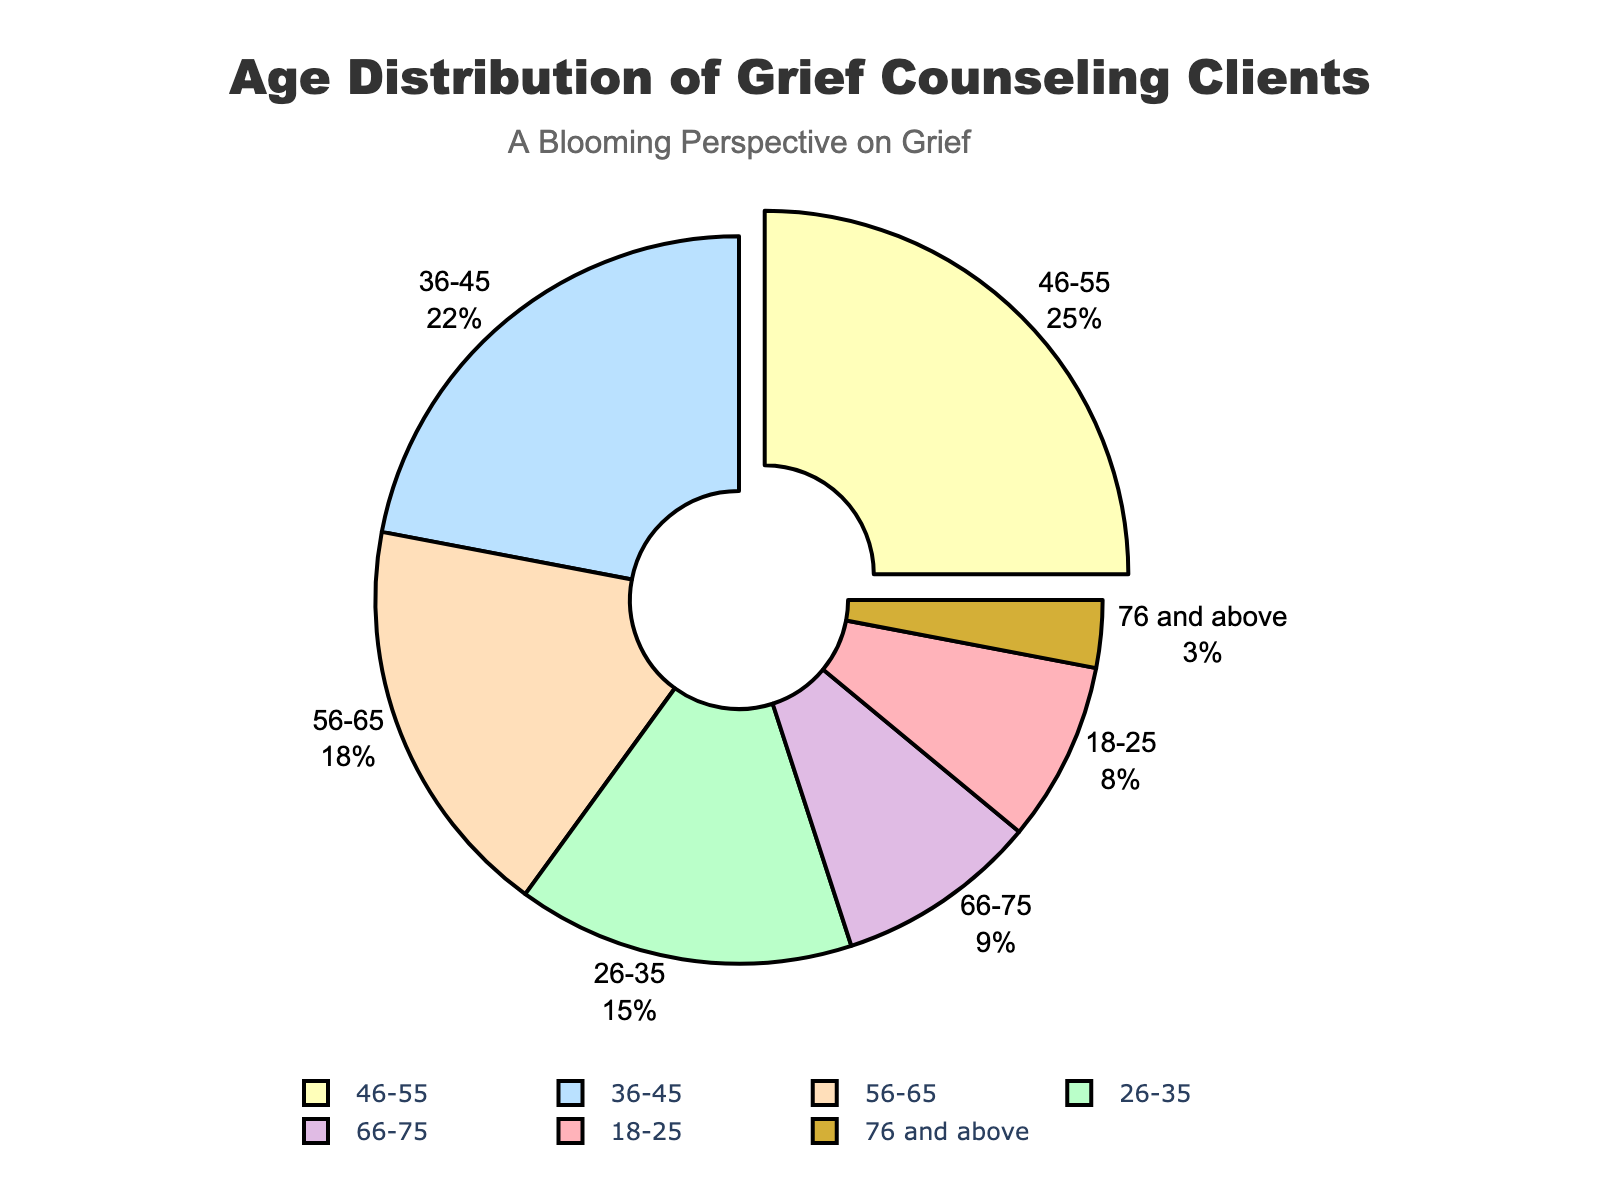What's the most represented age group among those seeking grief counseling? The chart shows the age groups along with their percentage values. The age group 46-55 has the highest percentage at 25%.
Answer: 46-55 Which age group has the smallest percentage of individuals? By observing the chart, the age group 76 and above has the smallest segment at 3%.
Answer: 76 and above What is the combined percentage of individuals aged 18-25 and 66-75 seeking grief counseling? The percentage for the age group 18-25 is 8%, and for 66-75 is 9%. Adding them together: 8 + 9 = 17%.
Answer: 17% What is the difference in percentage between the age groups 26-35 and 56-65? The percentage for the age group 26-35 is 15%, and for 56-65 is 18%. The difference is: 18 - 15 = 3%.
Answer: 3% Which age group has a higher percentage: 36-45 or 56-65? Observing the chart, the age group 36-45 has 22%, and the age group 56-65 has 18%. Since 22% is greater than 18%, the 36-45 group is higher.
Answer: 36-45 By how much does the percentage of the 46-55 age group exceed that of the 66-75 age group? The 46-55 age group has 25%, and the 66-75 age group has 9%. Subtracting these: 25 - 9 = 16%.
Answer: 16% Would you say the distribution of clients is more uniform or skewed? Observing the percentages, most age groups have similar values with a notable peak in the 46-55 category and a trough in the 76 and above category. This suggests a somewhat skewed distribution.
Answer: Skewed What's the total percentage of individuals aged 36-55 seeking grief counseling? The percentage for the age group 36-45 is 22%, and for 46-55 is 25%. Adding them together: 22 + 25 = 47%.
Answer: 47% How many age groups have a percentage less than 10%? From the chart, the age groups 18-25 (8%), 66-75 (9%), and 76 and above (3%) each have less than 10%. In total, that's three age groups.
Answer: 3 Which age group's segment is colored in yellow? Observing the chart, the yellow color is assigned to the age group 56-65.
Answer: 56-65 